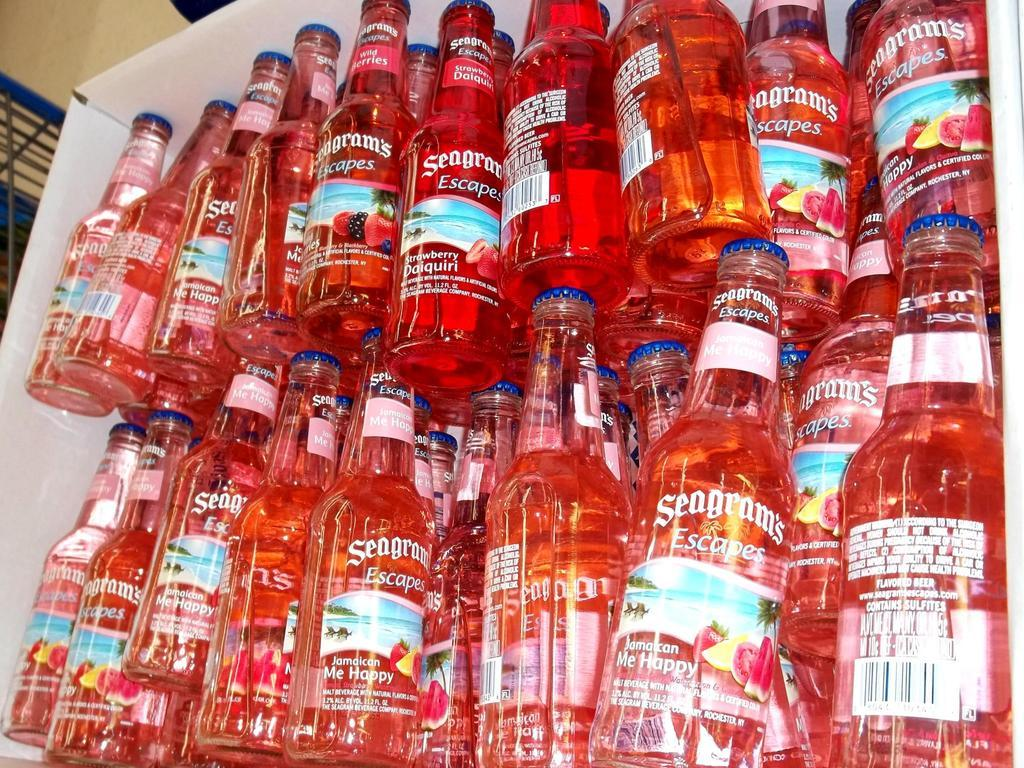What color are the bottles in the image? The bottles in the image are red. Is there snow visible in the image? There is no snow present in the image; it only features red color bottles. What type of bed can be seen in the image? There is no bed present in the image; it only red color bottles are visible. 